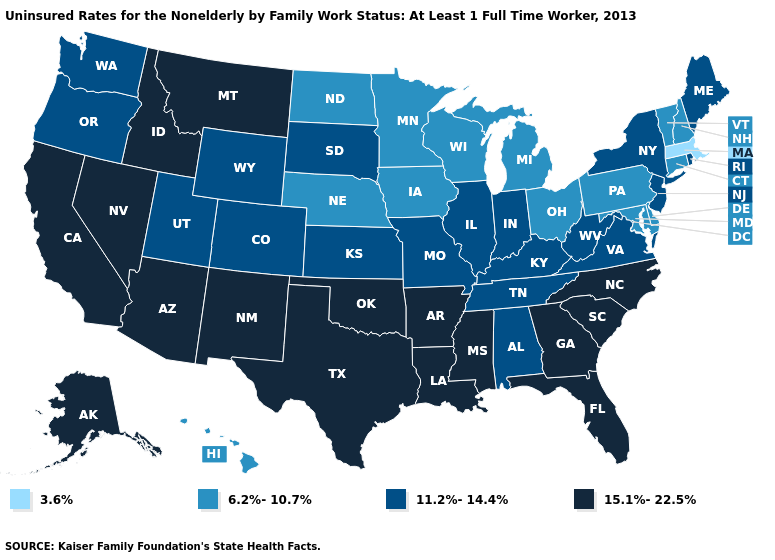Name the states that have a value in the range 15.1%-22.5%?
Answer briefly. Alaska, Arizona, Arkansas, California, Florida, Georgia, Idaho, Louisiana, Mississippi, Montana, Nevada, New Mexico, North Carolina, Oklahoma, South Carolina, Texas. Name the states that have a value in the range 6.2%-10.7%?
Answer briefly. Connecticut, Delaware, Hawaii, Iowa, Maryland, Michigan, Minnesota, Nebraska, New Hampshire, North Dakota, Ohio, Pennsylvania, Vermont, Wisconsin. What is the value of Virginia?
Short answer required. 11.2%-14.4%. Does Idaho have the highest value in the USA?
Short answer required. Yes. What is the highest value in the West ?
Write a very short answer. 15.1%-22.5%. What is the value of Missouri?
Answer briefly. 11.2%-14.4%. Does Texas have the highest value in the USA?
Short answer required. Yes. Does Massachusetts have the lowest value in the Northeast?
Be succinct. Yes. What is the value of Ohio?
Keep it brief. 6.2%-10.7%. Which states have the highest value in the USA?
Write a very short answer. Alaska, Arizona, Arkansas, California, Florida, Georgia, Idaho, Louisiana, Mississippi, Montana, Nevada, New Mexico, North Carolina, Oklahoma, South Carolina, Texas. Does Kentucky have the lowest value in the South?
Write a very short answer. No. Is the legend a continuous bar?
Keep it brief. No. What is the value of South Dakota?
Quick response, please. 11.2%-14.4%. What is the value of Florida?
Keep it brief. 15.1%-22.5%. 